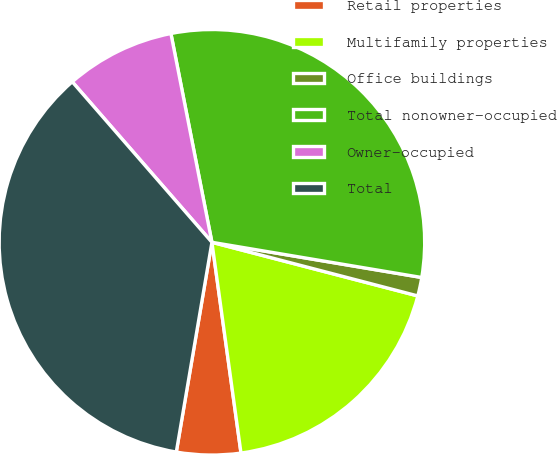Convert chart. <chart><loc_0><loc_0><loc_500><loc_500><pie_chart><fcel>Retail properties<fcel>Multifamily properties<fcel>Office buildings<fcel>Total nonowner-occupied<fcel>Owner-occupied<fcel>Total<nl><fcel>4.86%<fcel>18.76%<fcel>1.41%<fcel>30.73%<fcel>8.31%<fcel>35.92%<nl></chart> 